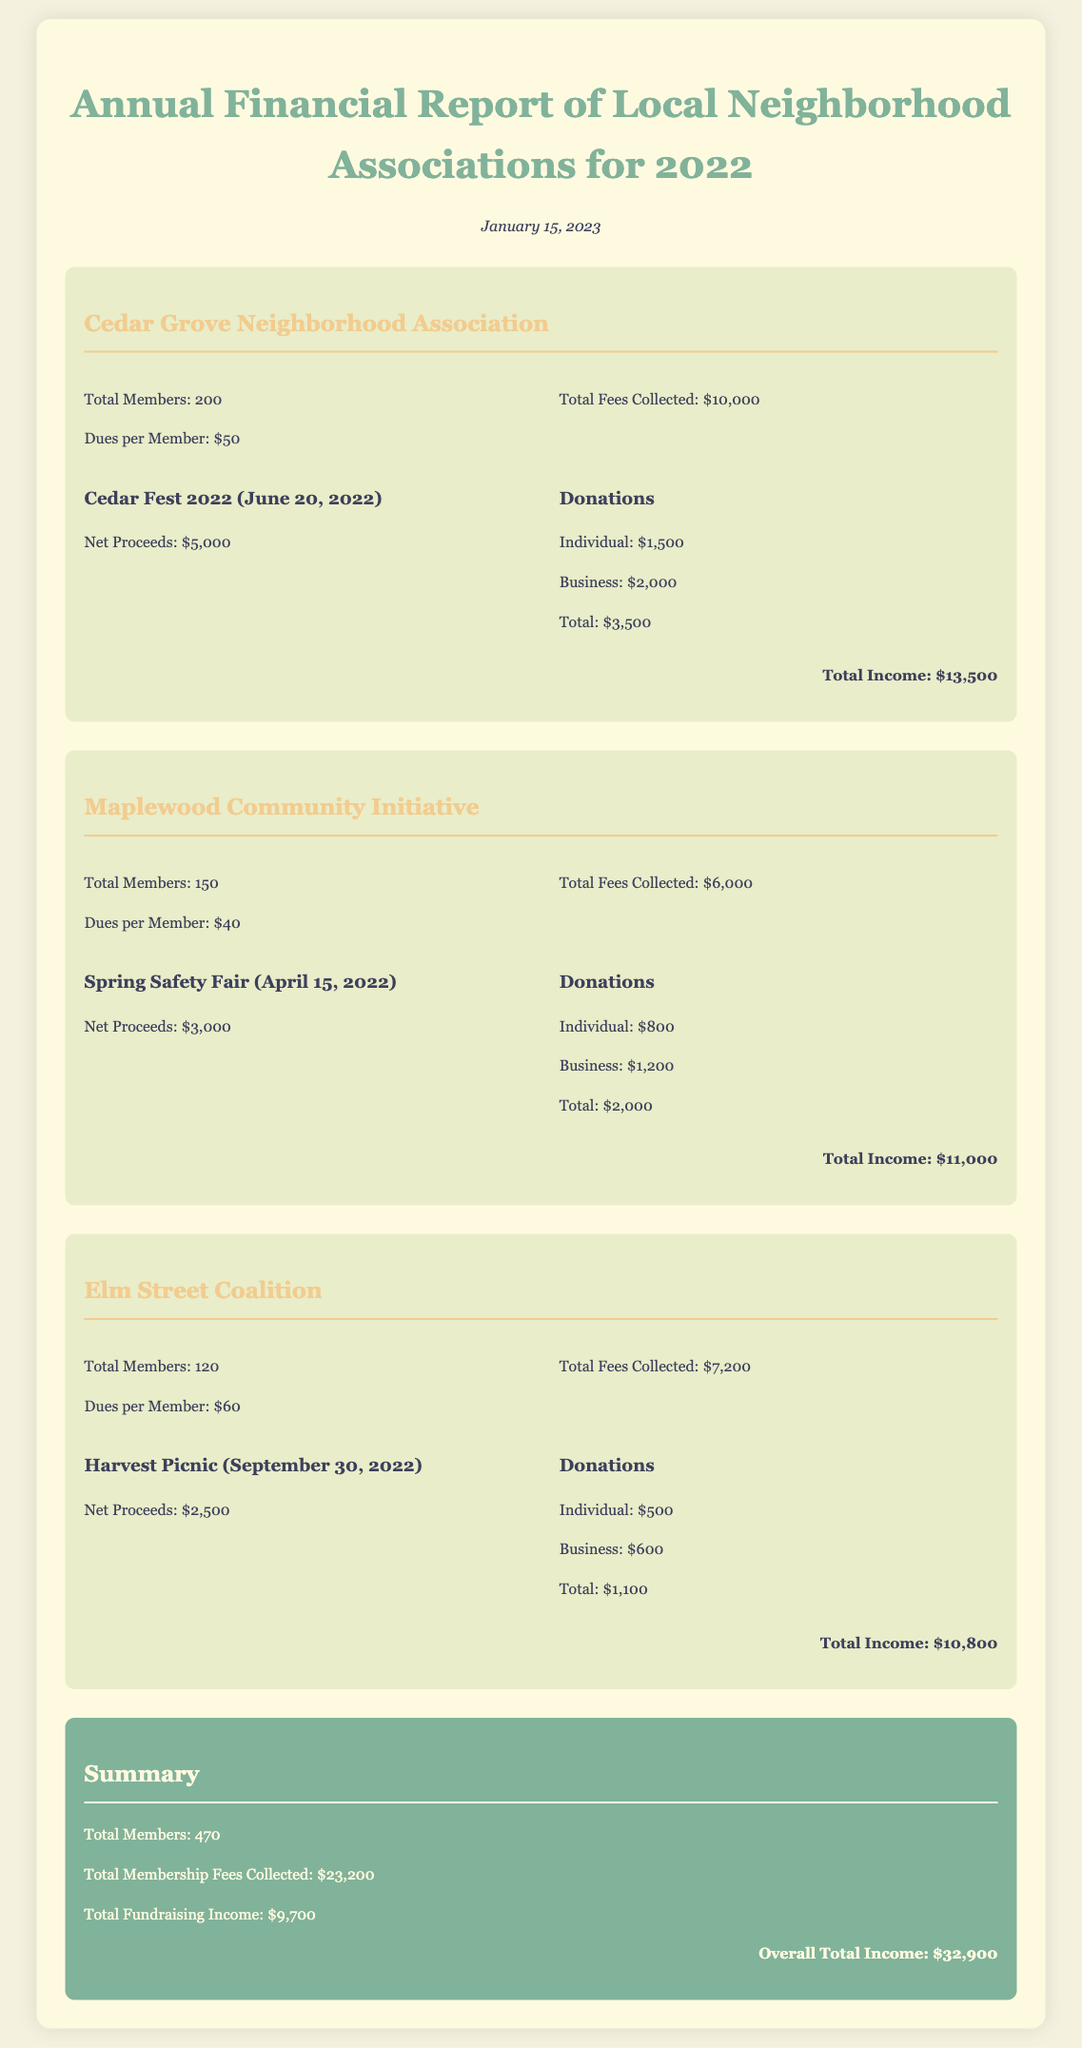What is the total amount collected from membership fees by the Cedar Grove Neighborhood Association? The Cedar Grove Neighborhood Association collected a total of $10,000 from membership fees.
Answer: $10,000 What event generated the highest net proceeds for Maplewood Community Initiative? The Spring Safety Fair generated the highest net proceeds of $3,000 for Maplewood Community Initiative.
Answer: Spring Safety Fair How many total members are there across all associations? The total number of members is the sum of all members from each association: 200 + 150 + 120 = 470.
Answer: 470 What was the total income for the Elm Street Coalition? The total income for the Elm Street Coalition is $10,800, as stated in the document.
Answer: $10,800 What is the total funding raised from donations for Cedar Grove Neighborhood Association? The total funding raised from donations for Cedar Grove Neighborhood Association is $3,500.
Answer: $3,500 Which neighborhood association has the highest dues per member? The Elm Street Coalition has the highest dues per member at $60.
Answer: $60 What are the total fundraising income values from all associations? The total fundraising income is the sum from all associations: $9,700 from fundraising activities reported.
Answer: $9,700 What is the date of the financial report publication? The financial report was published on January 15, 2023.
Answer: January 15, 2023 What were the total fees collected from all associations? The total fees collected from all associations is $23,200.
Answer: $23,200 